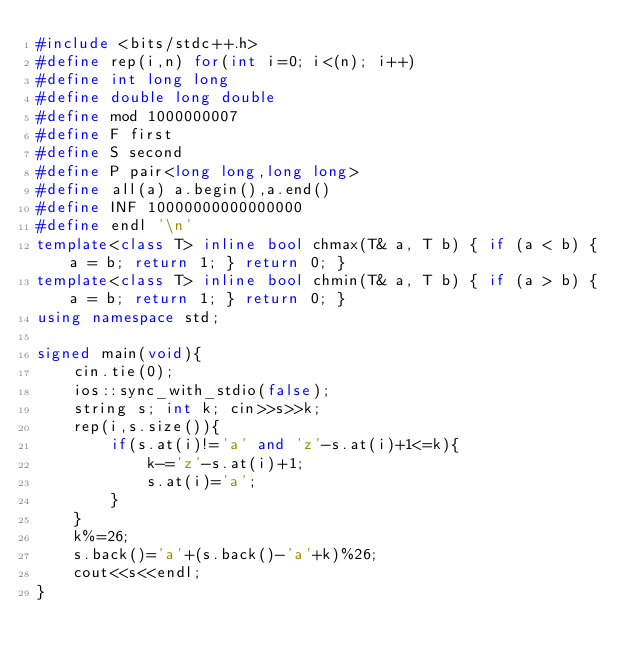<code> <loc_0><loc_0><loc_500><loc_500><_C++_>#include <bits/stdc++.h>
#define rep(i,n) for(int i=0; i<(n); i++)
#define int long long
#define double long double
#define mod 1000000007
#define F first
#define S second
#define P pair<long long,long long>
#define all(a) a.begin(),a.end()
#define INF 10000000000000000
#define endl '\n'
template<class T> inline bool chmax(T& a, T b) { if (a < b) { a = b; return 1; } return 0; }
template<class T> inline bool chmin(T& a, T b) { if (a > b) { a = b; return 1; } return 0; }
using namespace std;

signed main(void){
    cin.tie(0);
    ios::sync_with_stdio(false);
    string s; int k; cin>>s>>k;
    rep(i,s.size()){
        if(s.at(i)!='a' and 'z'-s.at(i)+1<=k){
            k-='z'-s.at(i)+1;
            s.at(i)='a';
        }
    }
    k%=26;
    s.back()='a'+(s.back()-'a'+k)%26;
    cout<<s<<endl;
}</code> 